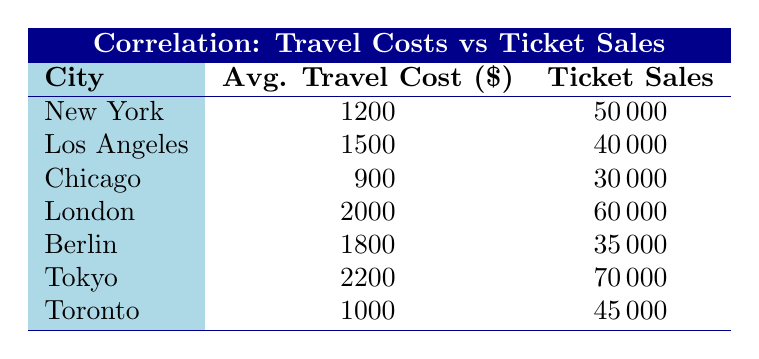What is the average travel cost in London? The average travel cost in London, as shown in the table, is directly listed as 2000.
Answer: 2000 Which city has the highest concert ticket sales? Tokyo has the highest concert ticket sales listed in the table, at 70000.
Answer: Tokyo What are the concert ticket sales for cities with an average travel cost higher than 1500? The cities with average travel costs higher than 1500 are Los Angeles (40000), London (60000), Berlin (35000), and Tokyo (70000). The sales for these cities are: 40000, 60000, 35000, and 70000, respectively.
Answer: 40000, 60000, 35000, 70000 Is the concert ticket sales in Tokyo greater than that in New York? Yes, the concert ticket sales in Tokyo (70000) are greater than those in New York (50000) as presented in the table.
Answer: Yes What is the difference in travel costs between Chicago and Los Angeles? Chicago's average travel cost is 900, while Los Angeles' is 1500. The difference is 1500 - 900 = 600.
Answer: 600 Which city has the least travel cost and what is its ticket sales? Chicago has the least travel cost at 900, and its corresponding ticket sales are 30000 as per the table.
Answer: Chicago, 30000 If we average the concert ticket sales of all cities, what is the result? To find the average, add all the ticket sales together: 50000 + 40000 + 30000 + 60000 + 35000 + 70000 + 45000 = 330000. Then, divide by the number of cities (7): 330000 / 7 = 47142.86.
Answer: 47142.86 Are travel costs associated with higher ticket sales generally? Yes, generally, cities with higher travel costs like Tokyo and London have higher concert ticket sales, indicating a positive correlation.
Answer: Yes What is the total ticket sales for cities with an average travel cost of 1000 or lower? The cities with average travel costs of 1000 or lower are Chicago (30000) and Toronto (45000). The total ticket sales would be 30000 + 45000 = 75000.
Answer: 75000 